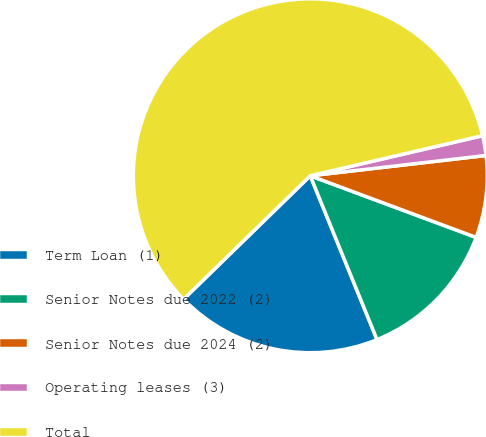<chart> <loc_0><loc_0><loc_500><loc_500><pie_chart><fcel>Term Loan (1)<fcel>Senior Notes due 2022 (2)<fcel>Senior Notes due 2024 (2)<fcel>Operating leases (3)<fcel>Total<nl><fcel>18.86%<fcel>13.18%<fcel>7.49%<fcel>1.81%<fcel>58.65%<nl></chart> 